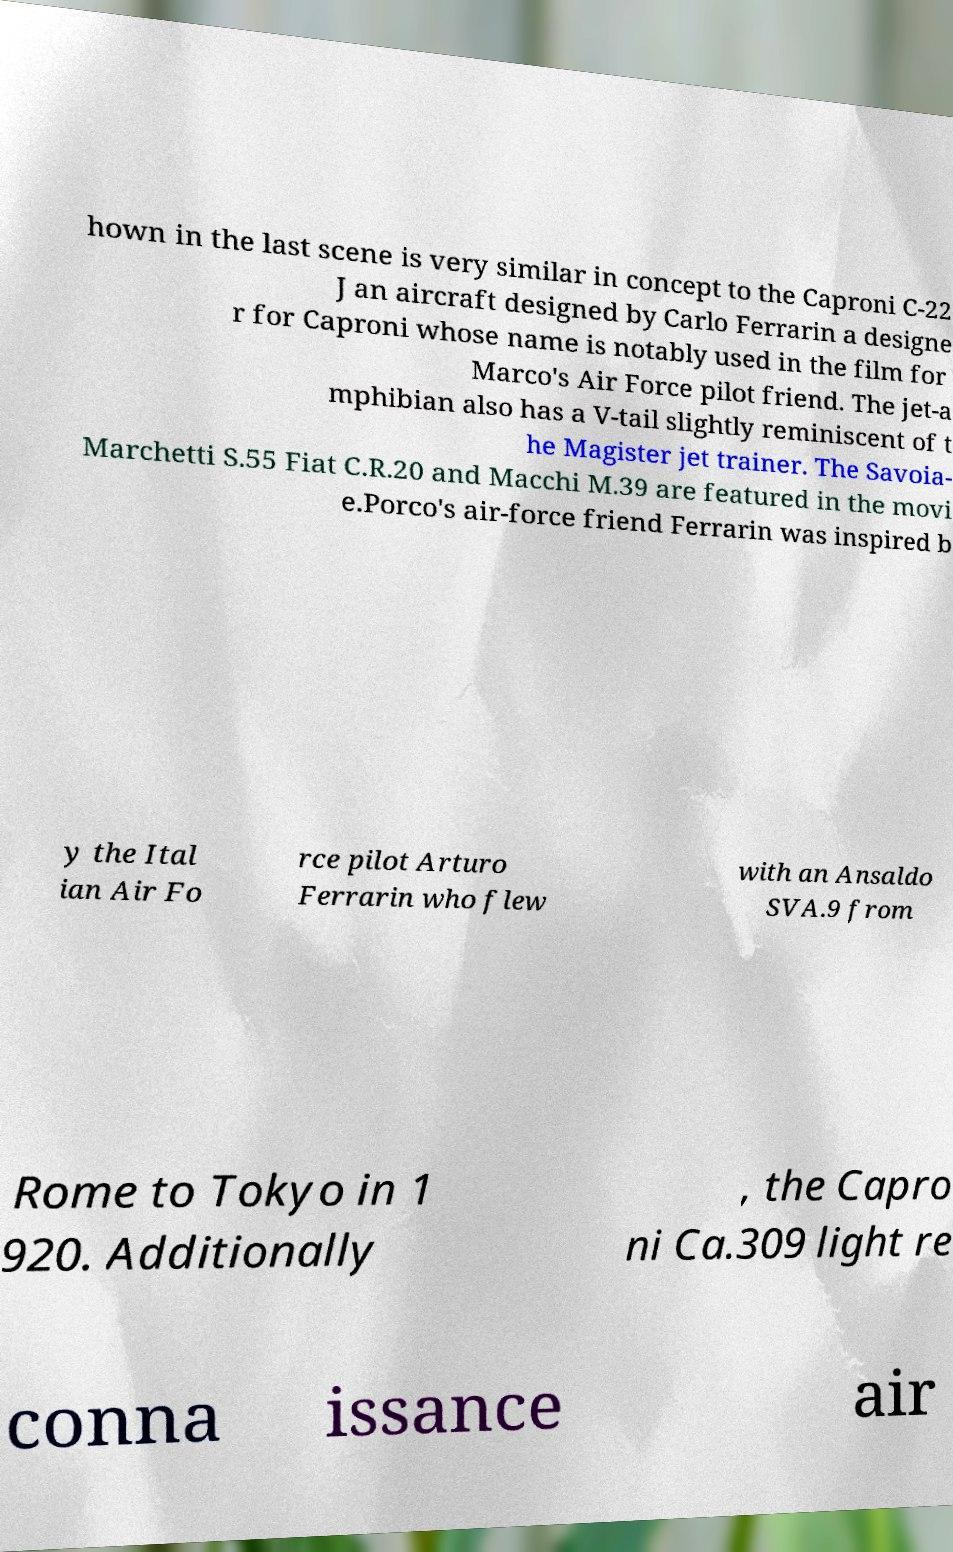For documentation purposes, I need the text within this image transcribed. Could you provide that? hown in the last scene is very similar in concept to the Caproni C-22 J an aircraft designed by Carlo Ferrarin a designe r for Caproni whose name is notably used in the film for Marco's Air Force pilot friend. The jet-a mphibian also has a V-tail slightly reminiscent of t he Magister jet trainer. The Savoia- Marchetti S.55 Fiat C.R.20 and Macchi M.39 are featured in the movi e.Porco's air-force friend Ferrarin was inspired b y the Ital ian Air Fo rce pilot Arturo Ferrarin who flew with an Ansaldo SVA.9 from Rome to Tokyo in 1 920. Additionally , the Capro ni Ca.309 light re conna issance air 